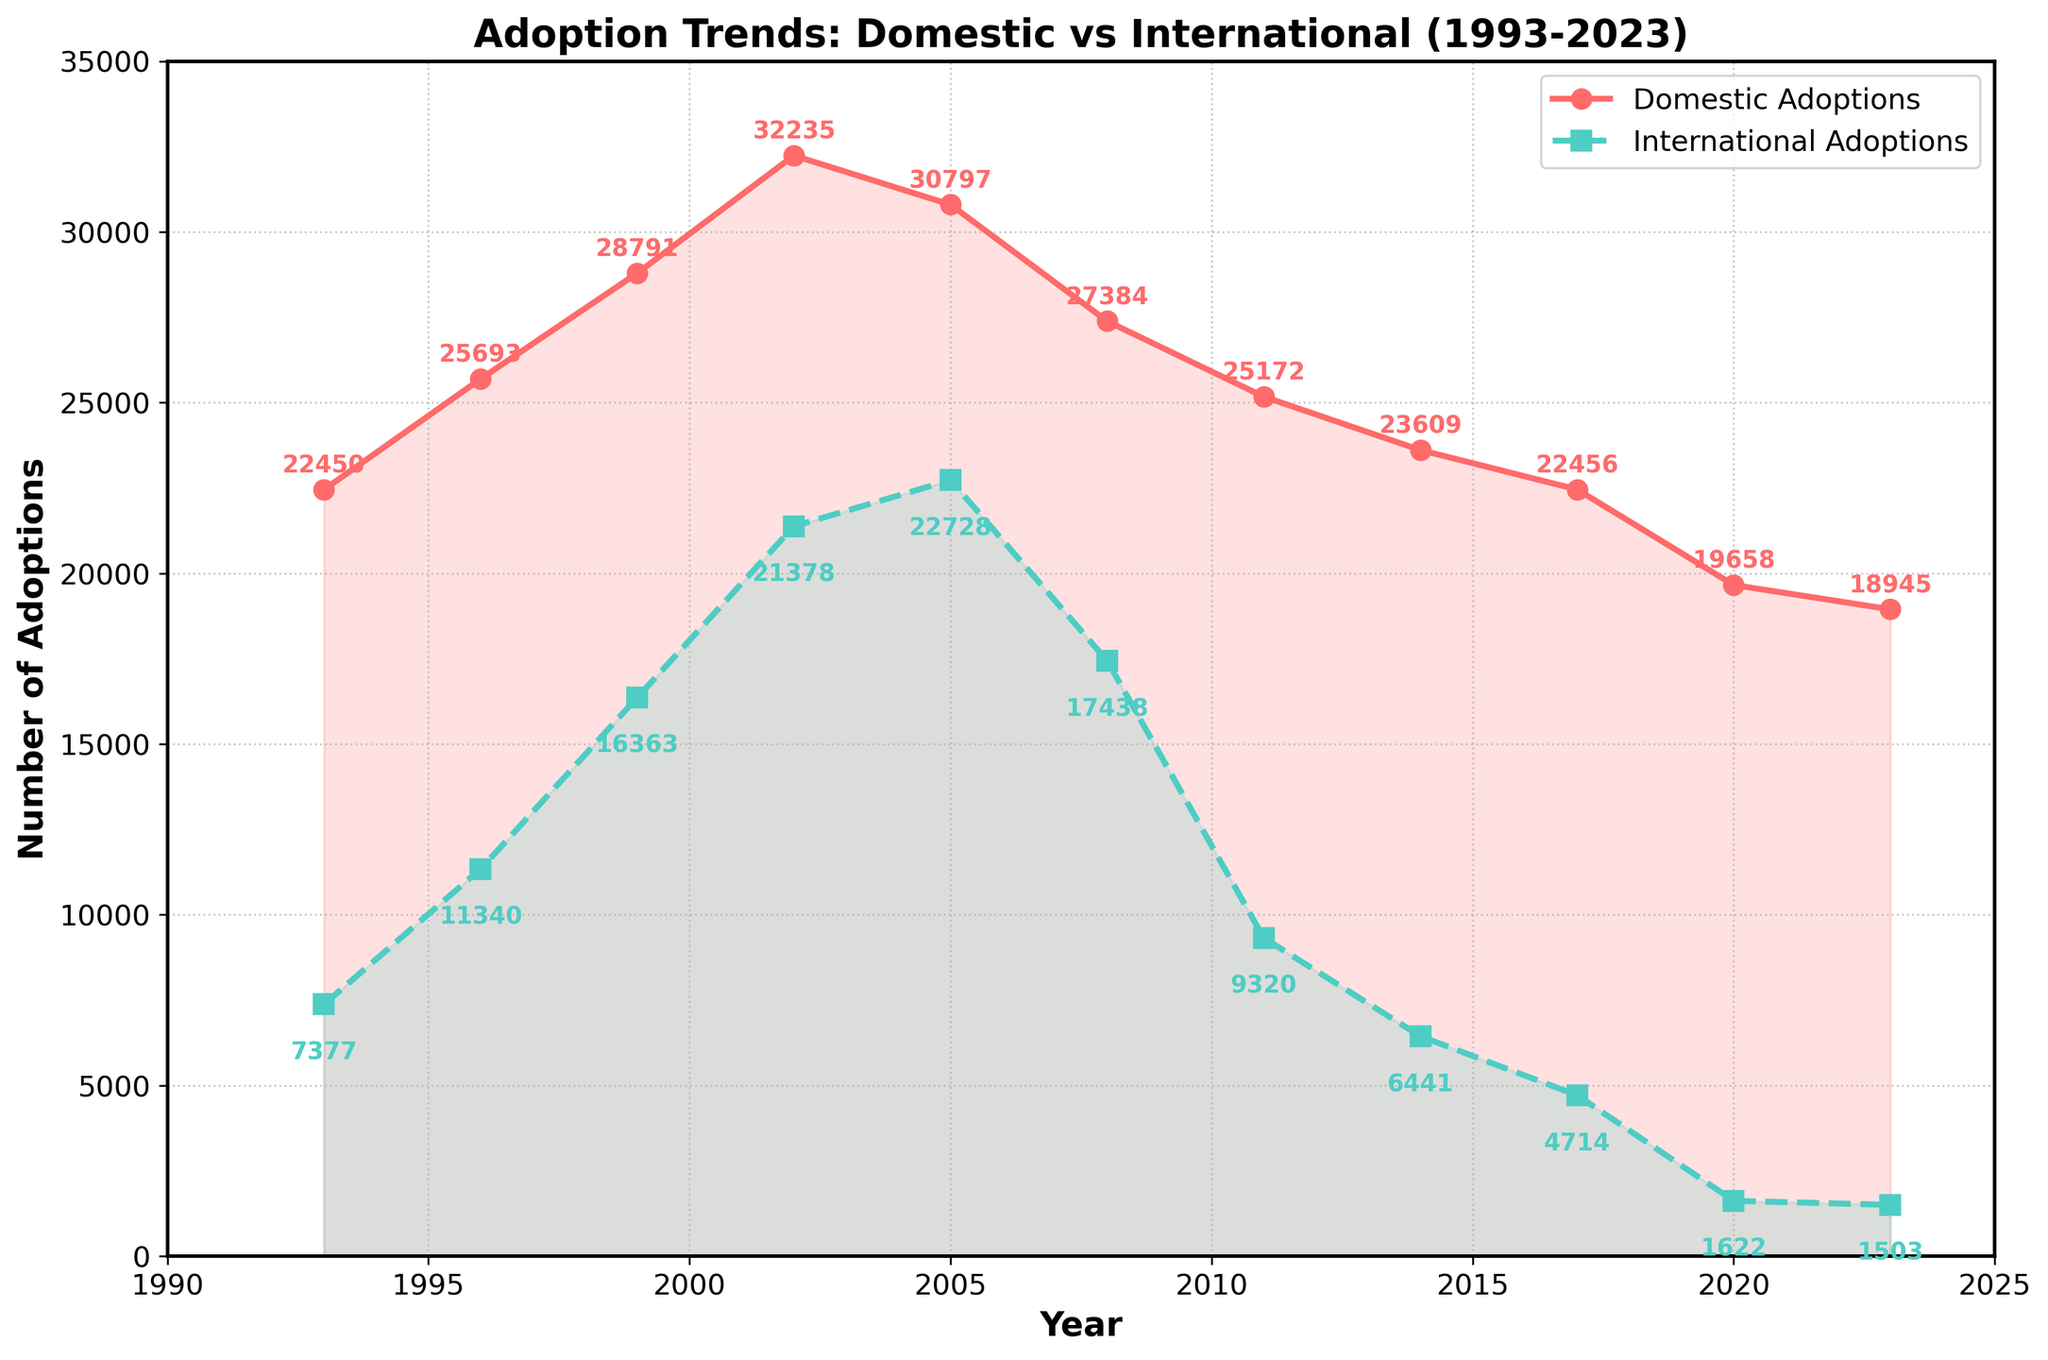What was the highest number of domestic adoptions recorded? The highest value for domestic adoptions can be found by noting the peak point of the line representing domestic adoptions. In this case, it is 32,235 in the year 2002.
Answer: 32,235 In which year did international adoptions peak, and what was the number? To identify the peak year, look for the highest point on the line representing international adoptions. This peak occurs in the year 2005 with 22,728 adoptions.
Answer: 2005, 22,728 How did the number of domestic adoptions change from 1993 to 2023? Subtract the number of domestic adoptions in 1993 from those in 2023. The calculation is 18,945 (2023) - 22,450 (1993) which equals a decrease of 3,505.
Answer: Decreased by 3,505 Compare the number of international adoptions in 2005 and 2023. How many more adoptions were there in 2005 compared to 2023? Find the difference between the two years by subtracting the 2023 value from the 2005 value. This is 22,728 - 1,503 which equals 21,225 more adoptions in 2005.
Answer: 21,225 more What is the average number of domestic adoptions from 1993 to 2023? Sum all the domestic adoption values and divide by the number of years. The sum is 22,450 + 25,693 + 28,791 + 32,235 + 30,797 + 27,384 + 25,172 + 23,609 + 22,456 + 19,658 + 18,945 which equals 277,190. Dividing by 11 years, the average is 25,290.9.
Answer: 25,290.9 During which years did both domestic and international adoptions decrease compared to the previous year? Identify the years where both lines are descending compared to their immediate prior year. Both domestic and international adoptions decreased in 2008, 2011, 2014, and 2017.
Answer: 2008, 2011, 2014, 2017 How does the length of the red section compare to the green section over the entire timeline? By visually assessing the overall height covered by the red (domestic adoptions) line compared to the green (international adoptions) line, you can observe that the red section is consistently higher and covers a more extended range than the green section over most years.
Answer: Red section is higher What's the difference in the number of domestic adoptions between the years 2005 and 2008, and what overarching trend does this reflect? Subtract the 2008 figure from the 2005 figure. Calculate 30,797 - 27,384, which equals 3,413 fewer adoptions in 2008. This reflects a broader trend of decline in recent years.
Answer: 3,413 fewer Which year shows the smallest gap between domestic and international adoptions, and what is the gap? Calculate the differences for each year and spot the smallest one. The differences are: 15,073 (1993), 14,353 (1996), 12,428 (1999), 10,857 (2002), 8,069 (2005), 9,946 (2008), 15,852 (2011), 16,168 (2014), 17,742 (2017), 18,036 (2020), and 17,442 (2023). The smallest gap is in 2005 with 8,069.
Answer: 2005, 8,069 